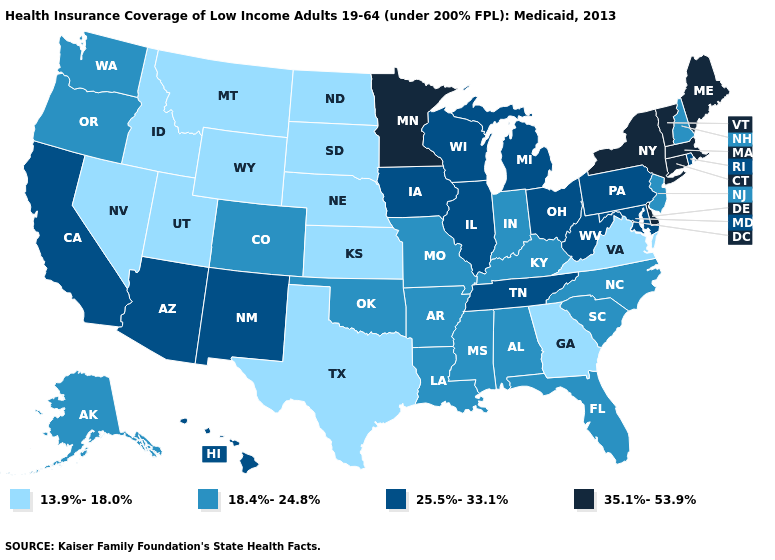Does the map have missing data?
Write a very short answer. No. Name the states that have a value in the range 35.1%-53.9%?
Short answer required. Connecticut, Delaware, Maine, Massachusetts, Minnesota, New York, Vermont. Among the states that border South Dakota , which have the lowest value?
Concise answer only. Montana, Nebraska, North Dakota, Wyoming. What is the highest value in states that border North Dakota?
Give a very brief answer. 35.1%-53.9%. What is the value of North Carolina?
Short answer required. 18.4%-24.8%. What is the value of North Carolina?
Quick response, please. 18.4%-24.8%. What is the value of North Carolina?
Concise answer only. 18.4%-24.8%. Does Texas have a lower value than North Dakota?
Be succinct. No. What is the lowest value in states that border Nebraska?
Short answer required. 13.9%-18.0%. Which states have the lowest value in the West?
Be succinct. Idaho, Montana, Nevada, Utah, Wyoming. What is the value of Virginia?
Answer briefly. 13.9%-18.0%. Does Pennsylvania have a lower value than Maryland?
Short answer required. No. Does Tennessee have the highest value in the South?
Give a very brief answer. No. What is the value of Alabama?
Give a very brief answer. 18.4%-24.8%. Name the states that have a value in the range 25.5%-33.1%?
Be succinct. Arizona, California, Hawaii, Illinois, Iowa, Maryland, Michigan, New Mexico, Ohio, Pennsylvania, Rhode Island, Tennessee, West Virginia, Wisconsin. 